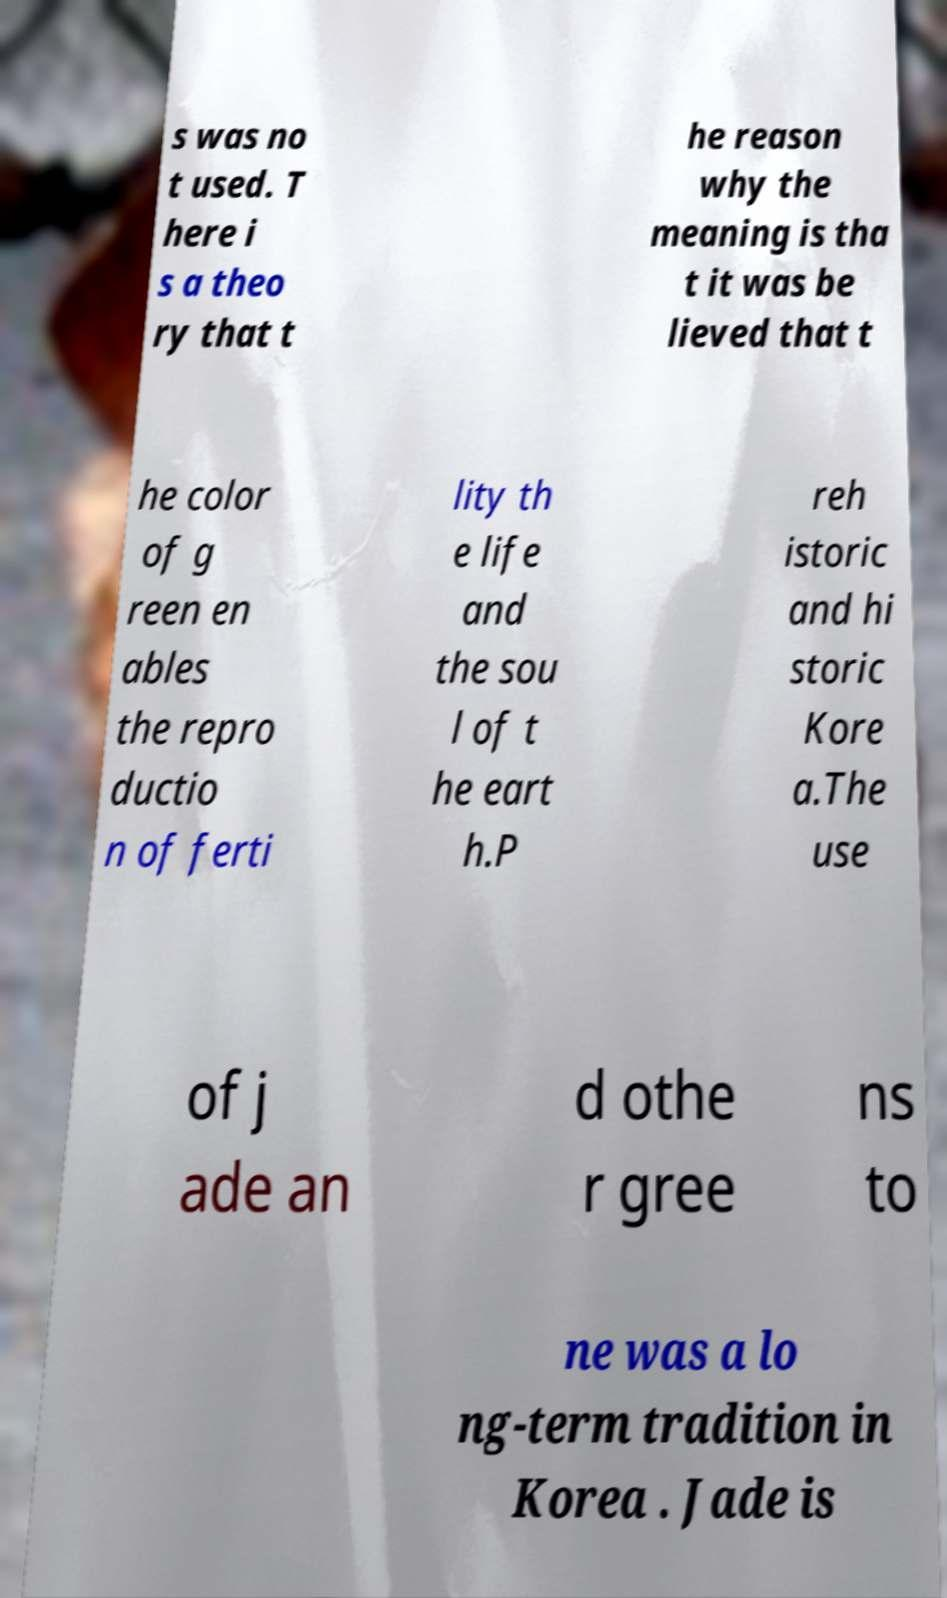Could you assist in decoding the text presented in this image and type it out clearly? s was no t used. T here i s a theo ry that t he reason why the meaning is tha t it was be lieved that t he color of g reen en ables the repro ductio n of ferti lity th e life and the sou l of t he eart h.P reh istoric and hi storic Kore a.The use of j ade an d othe r gree ns to ne was a lo ng-term tradition in Korea . Jade is 